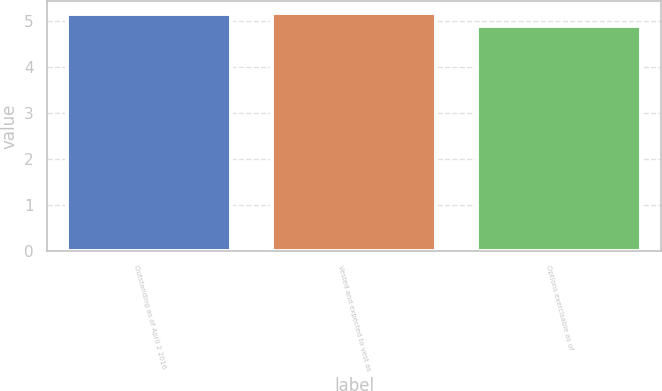Convert chart. <chart><loc_0><loc_0><loc_500><loc_500><bar_chart><fcel>Outstanding as of April 2 2016<fcel>Vested and expected to vest as<fcel>Options exercisable as of<nl><fcel>5.16<fcel>5.19<fcel>4.9<nl></chart> 